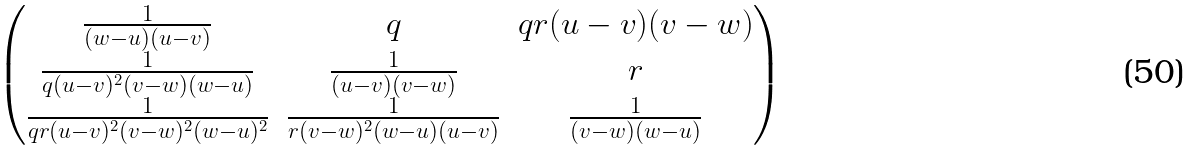<formula> <loc_0><loc_0><loc_500><loc_500>\begin{pmatrix} \frac { 1 } { ( w - u ) ( u - v ) } & q & q r ( u - v ) ( v - w ) \\ \frac { 1 } { q ( u - v ) ^ { 2 } ( v - w ) ( w - u ) } & \frac { 1 } { ( u - v ) ( v - w ) } & r \\ \frac { 1 } { q r ( u - v ) ^ { 2 } ( v - w ) ^ { 2 } ( w - u ) ^ { 2 } } & \frac { 1 } { r ( v - w ) ^ { 2 } ( w - u ) ( u - v ) } & \frac { 1 } { ( v - w ) ( w - u ) } \end{pmatrix}</formula> 